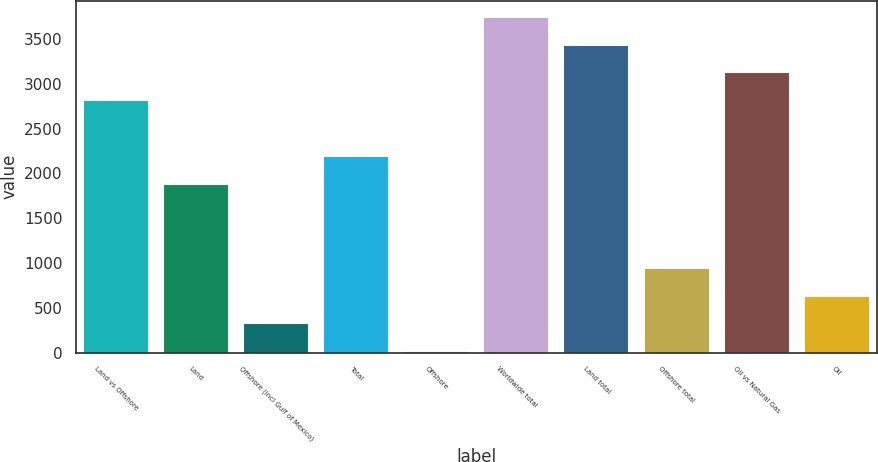<chart> <loc_0><loc_0><loc_500><loc_500><bar_chart><fcel>Land vs Offshore<fcel>Land<fcel>Offshore (incl Gulf of Mexico)<fcel>Total<fcel>Offshore<fcel>Worldwide total<fcel>Land total<fcel>Offshore total<fcel>Oil vs Natural Gas<fcel>Oil<nl><fcel>2805.6<fcel>1871.4<fcel>314.4<fcel>2182.8<fcel>3<fcel>3739.8<fcel>3428.4<fcel>937.2<fcel>3117<fcel>625.8<nl></chart> 